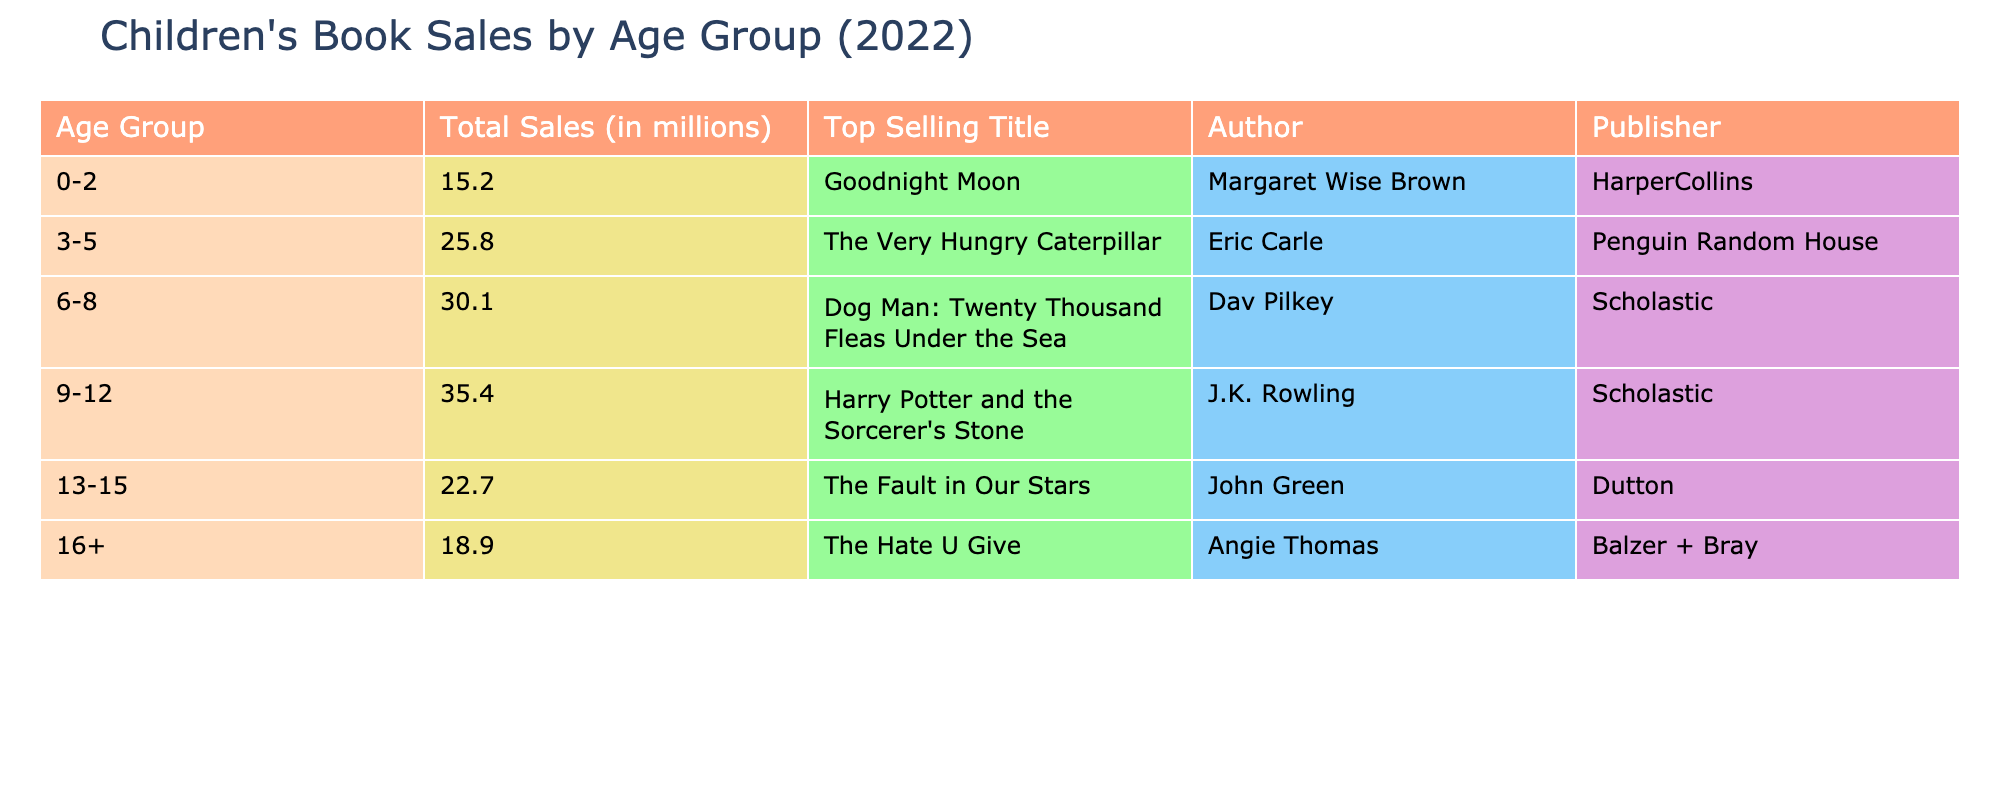What was the total sales for the age group 6-8? The total sales for the age group 6-8 is listed directly in the table under the "Total Sales (in millions)" column. The corresponding value next to the "6-8" age group is "30.1".
Answer: 30.1 million Which age group had the highest total sales in 2022? To determine this, I compare the total sales figures listed for each age group. The highest value is "35.4" next to the "9-12" age group.
Answer: 9-12 What is the average total sales across all age groups? To find the average, I first add the total sales for each age group: 15.2 + 25.8 + 30.1 + 35.4 + 22.7 + 18.9 = 148.1 million. Then, I divide this total by the number of age groups, which is 6: 148.1 / 6 = 24.6833. Rounding this gives approximately 24.68 million.
Answer: 24.68 million Did "The Fault in Our Stars" outsell "Goodnight Moon"? I will compare the total sales for each title listed. "The Fault in Our Stars" is associated with the age group 13-15, which has total sales of "22.7". "Goodnight Moon" belongs to the age group 0-2, which has total sales of "15.2". Since 22.7 is greater than 15.2, it confirms that "The Fault in Our Stars" outsold "Goodnight Moon".
Answer: Yes What is the difference in total sales between the age groups 3-5 and 16+? First, I identify the total sales for both age groups: for 3-5 it is "25.8" and for 16+ it is "18.9". I subtract the lower sales from the higher: 25.8 - 18.9 = 6.9 million.
Answer: 6.9 million Which author wrote the top-selling title for the age group 9-12? The top selling title for the age group 9-12 is "Harry Potter and the Sorcerer's Stone" and the author is listed next to it in the table as "J.K. Rowling".
Answer: J.K. Rowling Is the publisher for "The Very Hungry Caterpillar" the same as for "Dog Man: Twenty Thousand Fleas Under the Sea"? To answer this, I look at the publishers of each title: the publisher for "The Very Hungry Caterpillar" is "Penguin Random House", and for "Dog Man: Twenty Thousand Fleas Under the Sea", it is "Scholastic". Since both publishers are different, the answer is no.
Answer: No What sales figure corresponds to the top-selling title for age group 0-2? The top-selling title for the age group 0-2 is "Goodnight Moon," and its corresponding sales figure is listed in the "Total Sales (in millions)" column as "15.2".
Answer: 15.2 million 